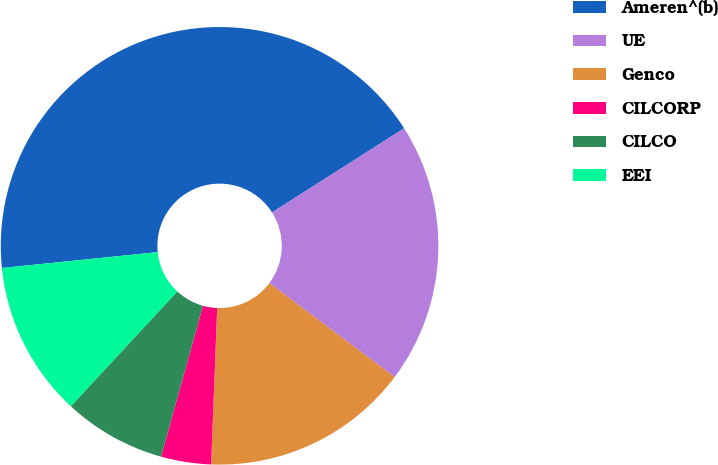<chart> <loc_0><loc_0><loc_500><loc_500><pie_chart><fcel>Ameren^(b)<fcel>UE<fcel>Genco<fcel>CILCORP<fcel>CILCO<fcel>EEI<nl><fcel>42.59%<fcel>19.26%<fcel>15.37%<fcel>3.7%<fcel>7.59%<fcel>11.48%<nl></chart> 